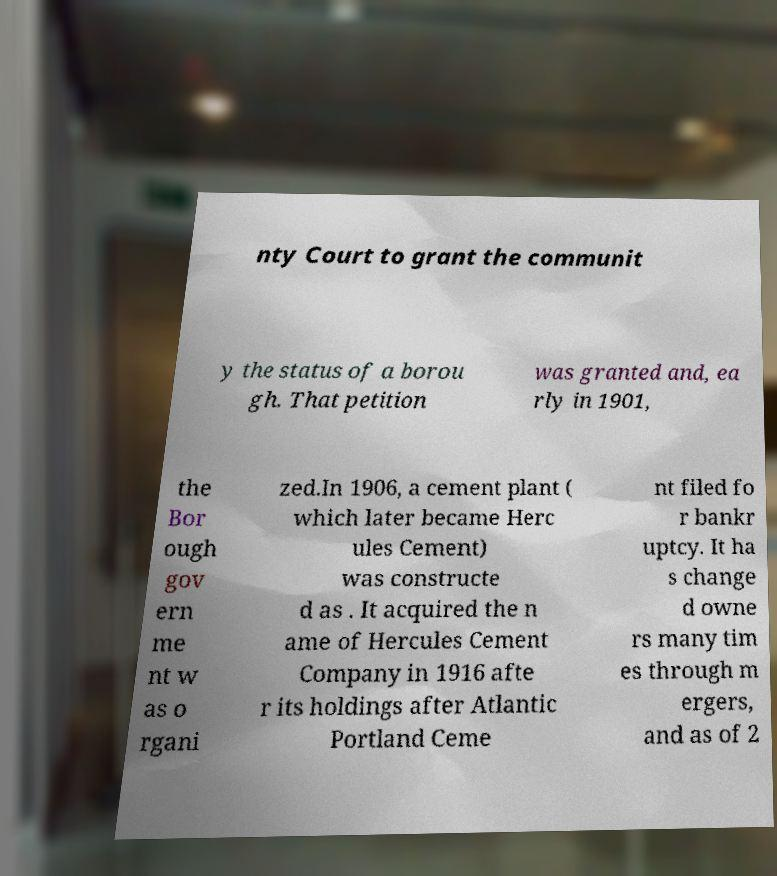Can you read and provide the text displayed in the image?This photo seems to have some interesting text. Can you extract and type it out for me? nty Court to grant the communit y the status of a borou gh. That petition was granted and, ea rly in 1901, the Bor ough gov ern me nt w as o rgani zed.In 1906, a cement plant ( which later became Herc ules Cement) was constructe d as . It acquired the n ame of Hercules Cement Company in 1916 afte r its holdings after Atlantic Portland Ceme nt filed fo r bankr uptcy. It ha s change d owne rs many tim es through m ergers, and as of 2 